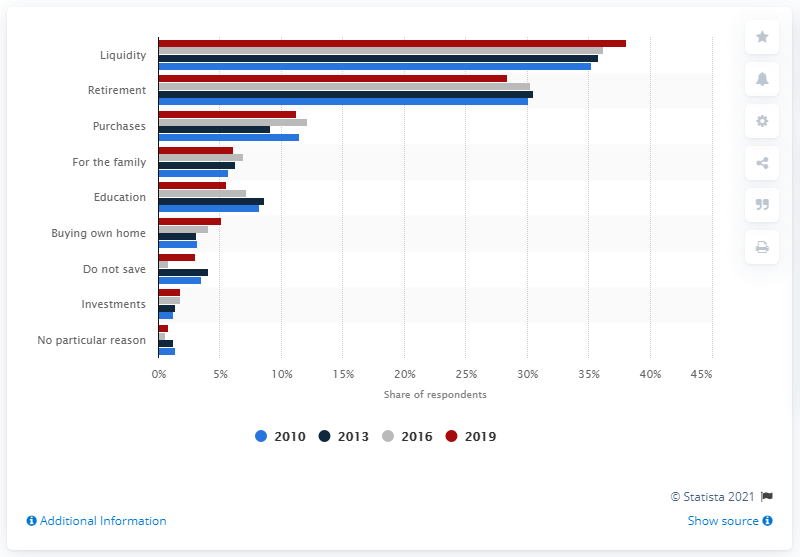Give some essential details in this illustration. A survey found that 38.1% of American families reported saving to buy their own home. 